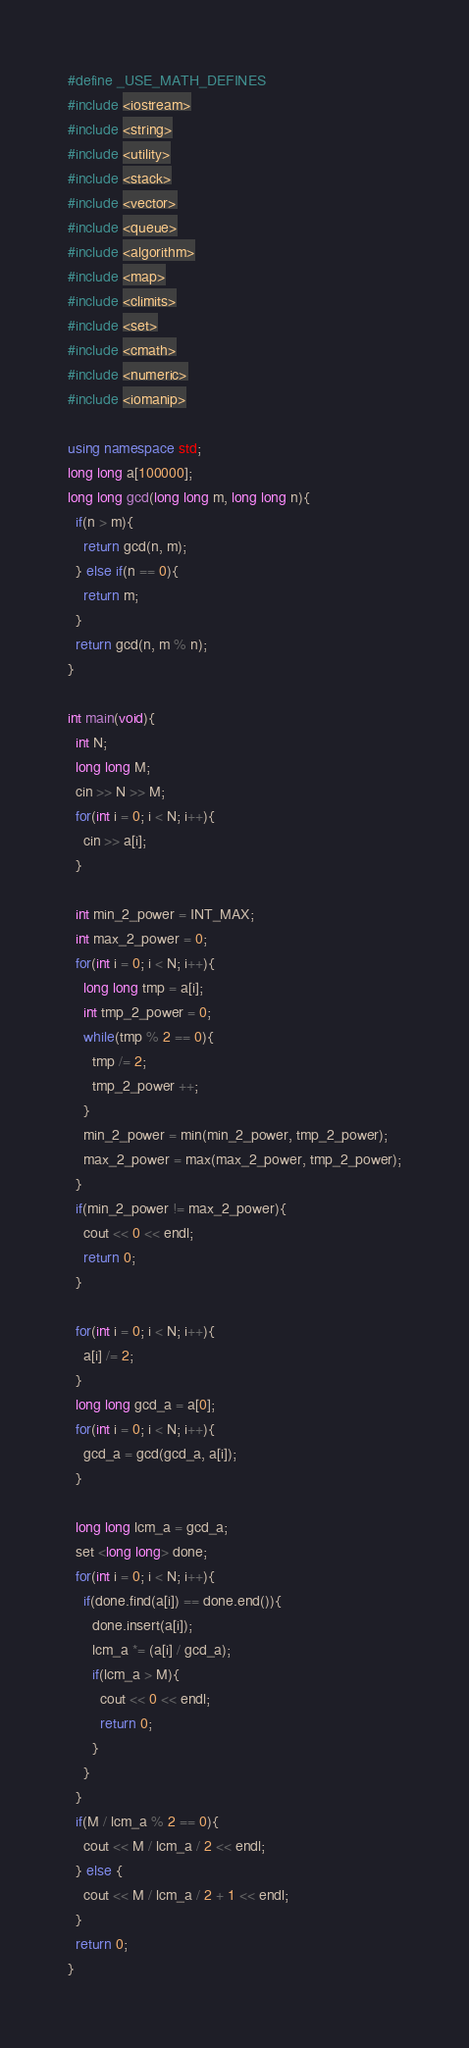<code> <loc_0><loc_0><loc_500><loc_500><_C++_>#define _USE_MATH_DEFINES
#include <iostream>
#include <string>
#include <utility>
#include <stack>
#include <vector>
#include <queue>
#include <algorithm>
#include <map>
#include <climits>
#include <set>
#include <cmath>
#include <numeric>
#include <iomanip>

using namespace std;
long long a[100000];
long long gcd(long long m, long long n){
  if(n > m){
    return gcd(n, m);
  } else if(n == 0){
    return m;
  }
  return gcd(n, m % n);
}

int main(void){
  int N;
  long long M;
  cin >> N >> M;
  for(int i = 0; i < N; i++){
    cin >> a[i];
  }

  int min_2_power = INT_MAX;
  int max_2_power = 0;
  for(int i = 0; i < N; i++){
    long long tmp = a[i];
    int tmp_2_power = 0;
    while(tmp % 2 == 0){
      tmp /= 2;
      tmp_2_power ++;
    }
    min_2_power = min(min_2_power, tmp_2_power);
    max_2_power = max(max_2_power, tmp_2_power);
  }
  if(min_2_power != max_2_power){
    cout << 0 << endl;
    return 0;
  }

  for(int i = 0; i < N; i++){
    a[i] /= 2;
  }
  long long gcd_a = a[0];
  for(int i = 0; i < N; i++){
    gcd_a = gcd(gcd_a, a[i]);
  }
  
  long long lcm_a = gcd_a;
  set <long long> done;
  for(int i = 0; i < N; i++){
    if(done.find(a[i]) == done.end()){
      done.insert(a[i]);
      lcm_a *= (a[i] / gcd_a);
      if(lcm_a > M){
        cout << 0 << endl;
        return 0;
      }
    }
  }
  if(M / lcm_a % 2 == 0){
    cout << M / lcm_a / 2 << endl;
  } else {
    cout << M / lcm_a / 2 + 1 << endl;
  }
  return 0;
}</code> 